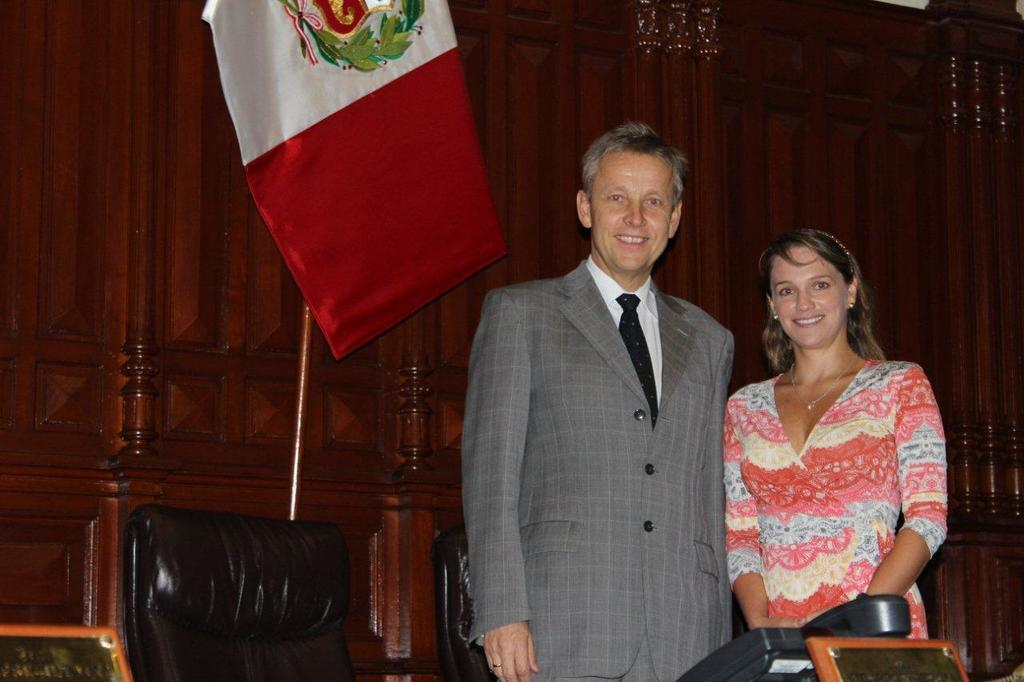Who can be seen in the image? There is a man and a lady in the image. What are the man and the lady doing in the image? Both the man and the lady are standing and smiling. What furniture is present in the image? There are chairs in the image. What communication device is visible at the bottom of the image? There is a telephone at the bottom of the image. What can be seen in the background of the image? There is a flag and a wall in the background of the image. Can you see any icicles forming on the wall in the image? There are no icicles present in the image; the wall and the overall setting suggest a warm environment. 